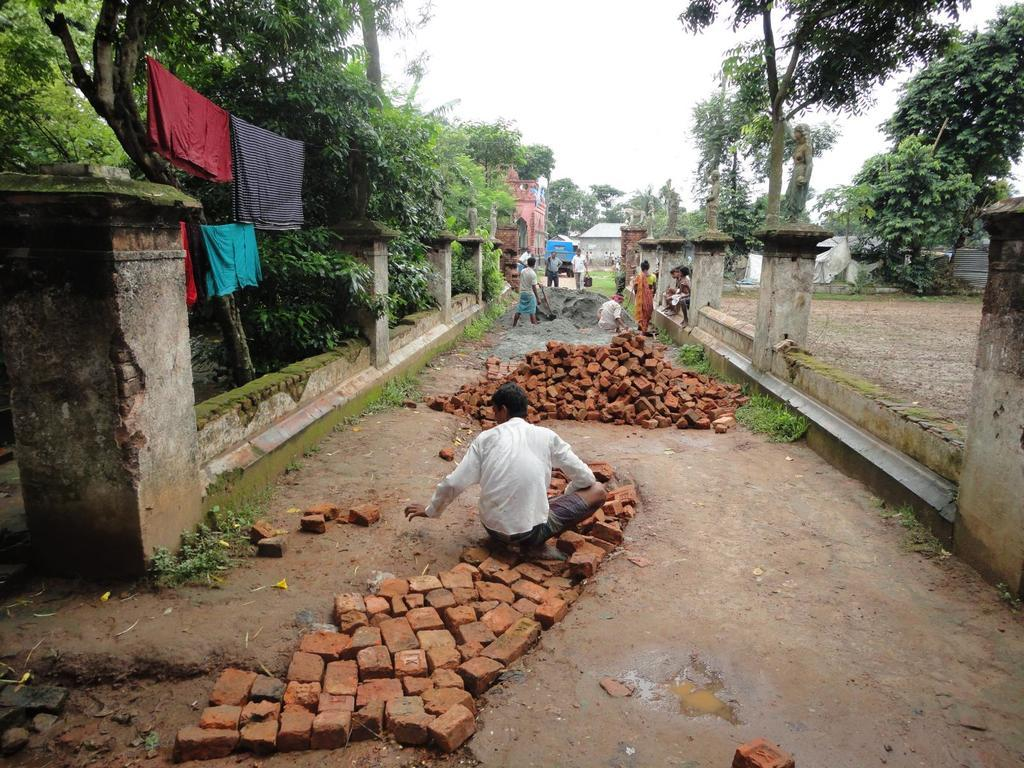Who or what can be seen in the image? There are people in the image. What type of material is visible in the image? There are bricks visible in the image. What architectural features are present in the image? There are pillars in the image. What type of vegetation is present in the image? There are trees in the image. What else is present in the image besides people and vegetation? Clothes are present in the image. What can be seen in the background of the image? There are buildings and the sky visible in the background of the image. What type of bell can be heard ringing in the image? There is no bell present or audible in the image. What type of feast is being prepared in the image? There is no indication of a feast or any food preparation in the image. 